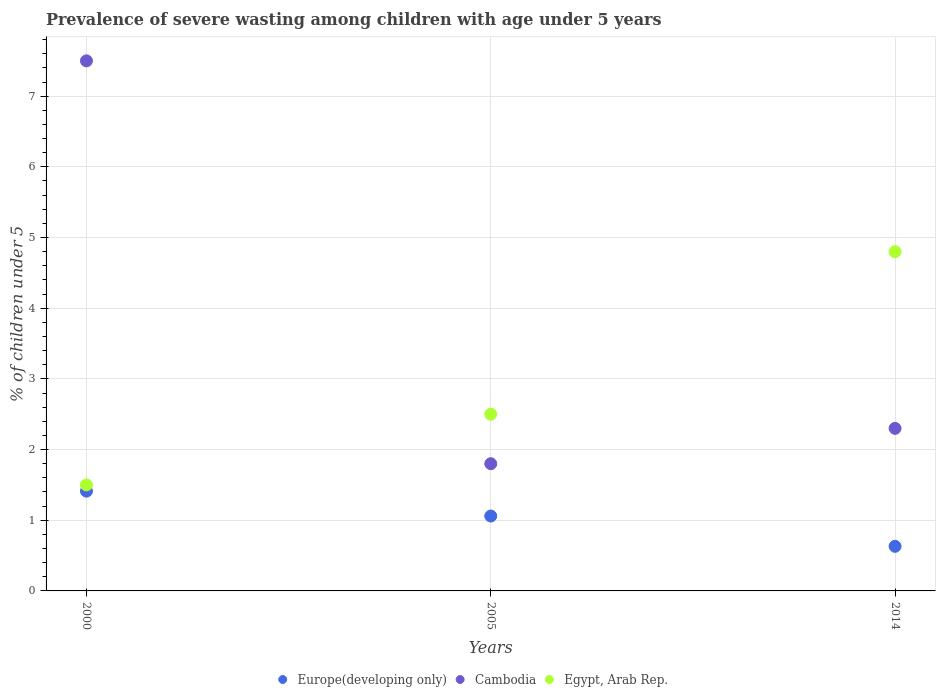How many different coloured dotlines are there?
Keep it short and to the point. 3. What is the percentage of severely wasted children in Europe(developing only) in 2005?
Your answer should be very brief. 1.06. Across all years, what is the maximum percentage of severely wasted children in Egypt, Arab Rep.?
Your answer should be very brief. 4.8. Across all years, what is the minimum percentage of severely wasted children in Cambodia?
Provide a short and direct response. 1.8. In which year was the percentage of severely wasted children in Egypt, Arab Rep. maximum?
Your answer should be compact. 2014. In which year was the percentage of severely wasted children in Egypt, Arab Rep. minimum?
Keep it short and to the point. 2000. What is the total percentage of severely wasted children in Europe(developing only) in the graph?
Ensure brevity in your answer.  3.1. What is the difference between the percentage of severely wasted children in Cambodia in 2000 and that in 2005?
Provide a short and direct response. 5.7. What is the difference between the percentage of severely wasted children in Egypt, Arab Rep. in 2014 and the percentage of severely wasted children in Europe(developing only) in 2005?
Offer a very short reply. 3.74. What is the average percentage of severely wasted children in Egypt, Arab Rep. per year?
Offer a terse response. 2.93. In the year 2000, what is the difference between the percentage of severely wasted children in Cambodia and percentage of severely wasted children in Europe(developing only)?
Your response must be concise. 6.09. In how many years, is the percentage of severely wasted children in Cambodia greater than 5.8 %?
Keep it short and to the point. 1. What is the ratio of the percentage of severely wasted children in Egypt, Arab Rep. in 2000 to that in 2014?
Provide a succinct answer. 0.31. What is the difference between the highest and the second highest percentage of severely wasted children in Cambodia?
Your response must be concise. 5.2. What is the difference between the highest and the lowest percentage of severely wasted children in Europe(developing only)?
Your answer should be compact. 0.78. In how many years, is the percentage of severely wasted children in Egypt, Arab Rep. greater than the average percentage of severely wasted children in Egypt, Arab Rep. taken over all years?
Ensure brevity in your answer.  1. Is the sum of the percentage of severely wasted children in Europe(developing only) in 2005 and 2014 greater than the maximum percentage of severely wasted children in Cambodia across all years?
Keep it short and to the point. No. Is the percentage of severely wasted children in Cambodia strictly greater than the percentage of severely wasted children in Europe(developing only) over the years?
Ensure brevity in your answer.  Yes. Is the percentage of severely wasted children in Europe(developing only) strictly less than the percentage of severely wasted children in Egypt, Arab Rep. over the years?
Give a very brief answer. Yes. How many dotlines are there?
Make the answer very short. 3. How many years are there in the graph?
Offer a terse response. 3. Does the graph contain grids?
Your answer should be compact. Yes. How many legend labels are there?
Keep it short and to the point. 3. How are the legend labels stacked?
Provide a short and direct response. Horizontal. What is the title of the graph?
Provide a succinct answer. Prevalence of severe wasting among children with age under 5 years. Does "Papua New Guinea" appear as one of the legend labels in the graph?
Offer a terse response. No. What is the label or title of the X-axis?
Offer a very short reply. Years. What is the label or title of the Y-axis?
Give a very brief answer. % of children under 5. What is the % of children under 5 of Europe(developing only) in 2000?
Your answer should be compact. 1.41. What is the % of children under 5 of Egypt, Arab Rep. in 2000?
Your answer should be compact. 1.5. What is the % of children under 5 of Europe(developing only) in 2005?
Give a very brief answer. 1.06. What is the % of children under 5 in Cambodia in 2005?
Your answer should be very brief. 1.8. What is the % of children under 5 of Europe(developing only) in 2014?
Offer a terse response. 0.63. What is the % of children under 5 of Cambodia in 2014?
Keep it short and to the point. 2.3. What is the % of children under 5 in Egypt, Arab Rep. in 2014?
Offer a very short reply. 4.8. Across all years, what is the maximum % of children under 5 of Europe(developing only)?
Ensure brevity in your answer.  1.41. Across all years, what is the maximum % of children under 5 in Egypt, Arab Rep.?
Ensure brevity in your answer.  4.8. Across all years, what is the minimum % of children under 5 in Europe(developing only)?
Your answer should be compact. 0.63. Across all years, what is the minimum % of children under 5 in Cambodia?
Offer a very short reply. 1.8. Across all years, what is the minimum % of children under 5 in Egypt, Arab Rep.?
Ensure brevity in your answer.  1.5. What is the total % of children under 5 in Europe(developing only) in the graph?
Your response must be concise. 3.1. What is the total % of children under 5 of Cambodia in the graph?
Provide a short and direct response. 11.6. What is the total % of children under 5 in Egypt, Arab Rep. in the graph?
Your response must be concise. 8.8. What is the difference between the % of children under 5 of Europe(developing only) in 2000 and that in 2005?
Give a very brief answer. 0.35. What is the difference between the % of children under 5 of Europe(developing only) in 2000 and that in 2014?
Keep it short and to the point. 0.78. What is the difference between the % of children under 5 of Cambodia in 2000 and that in 2014?
Offer a very short reply. 5.2. What is the difference between the % of children under 5 of Egypt, Arab Rep. in 2000 and that in 2014?
Offer a very short reply. -3.3. What is the difference between the % of children under 5 in Europe(developing only) in 2005 and that in 2014?
Your answer should be compact. 0.43. What is the difference between the % of children under 5 of Egypt, Arab Rep. in 2005 and that in 2014?
Your answer should be very brief. -2.3. What is the difference between the % of children under 5 in Europe(developing only) in 2000 and the % of children under 5 in Cambodia in 2005?
Your response must be concise. -0.39. What is the difference between the % of children under 5 of Europe(developing only) in 2000 and the % of children under 5 of Egypt, Arab Rep. in 2005?
Your answer should be compact. -1.09. What is the difference between the % of children under 5 in Cambodia in 2000 and the % of children under 5 in Egypt, Arab Rep. in 2005?
Keep it short and to the point. 5. What is the difference between the % of children under 5 in Europe(developing only) in 2000 and the % of children under 5 in Cambodia in 2014?
Your answer should be very brief. -0.89. What is the difference between the % of children under 5 of Europe(developing only) in 2000 and the % of children under 5 of Egypt, Arab Rep. in 2014?
Offer a terse response. -3.39. What is the difference between the % of children under 5 in Europe(developing only) in 2005 and the % of children under 5 in Cambodia in 2014?
Keep it short and to the point. -1.24. What is the difference between the % of children under 5 of Europe(developing only) in 2005 and the % of children under 5 of Egypt, Arab Rep. in 2014?
Provide a short and direct response. -3.74. What is the difference between the % of children under 5 in Cambodia in 2005 and the % of children under 5 in Egypt, Arab Rep. in 2014?
Provide a short and direct response. -3. What is the average % of children under 5 of Europe(developing only) per year?
Your response must be concise. 1.03. What is the average % of children under 5 in Cambodia per year?
Your response must be concise. 3.87. What is the average % of children under 5 of Egypt, Arab Rep. per year?
Provide a short and direct response. 2.93. In the year 2000, what is the difference between the % of children under 5 of Europe(developing only) and % of children under 5 of Cambodia?
Your answer should be very brief. -6.09. In the year 2000, what is the difference between the % of children under 5 of Europe(developing only) and % of children under 5 of Egypt, Arab Rep.?
Keep it short and to the point. -0.09. In the year 2000, what is the difference between the % of children under 5 of Cambodia and % of children under 5 of Egypt, Arab Rep.?
Your response must be concise. 6. In the year 2005, what is the difference between the % of children under 5 in Europe(developing only) and % of children under 5 in Cambodia?
Provide a short and direct response. -0.74. In the year 2005, what is the difference between the % of children under 5 of Europe(developing only) and % of children under 5 of Egypt, Arab Rep.?
Your response must be concise. -1.44. In the year 2014, what is the difference between the % of children under 5 in Europe(developing only) and % of children under 5 in Cambodia?
Keep it short and to the point. -1.67. In the year 2014, what is the difference between the % of children under 5 of Europe(developing only) and % of children under 5 of Egypt, Arab Rep.?
Offer a very short reply. -4.17. In the year 2014, what is the difference between the % of children under 5 in Cambodia and % of children under 5 in Egypt, Arab Rep.?
Your answer should be very brief. -2.5. What is the ratio of the % of children under 5 of Europe(developing only) in 2000 to that in 2005?
Give a very brief answer. 1.33. What is the ratio of the % of children under 5 of Cambodia in 2000 to that in 2005?
Keep it short and to the point. 4.17. What is the ratio of the % of children under 5 of Europe(developing only) in 2000 to that in 2014?
Make the answer very short. 2.24. What is the ratio of the % of children under 5 of Cambodia in 2000 to that in 2014?
Keep it short and to the point. 3.26. What is the ratio of the % of children under 5 of Egypt, Arab Rep. in 2000 to that in 2014?
Offer a very short reply. 0.31. What is the ratio of the % of children under 5 in Europe(developing only) in 2005 to that in 2014?
Provide a succinct answer. 1.68. What is the ratio of the % of children under 5 of Cambodia in 2005 to that in 2014?
Your answer should be compact. 0.78. What is the ratio of the % of children under 5 in Egypt, Arab Rep. in 2005 to that in 2014?
Ensure brevity in your answer.  0.52. What is the difference between the highest and the second highest % of children under 5 of Europe(developing only)?
Your answer should be very brief. 0.35. What is the difference between the highest and the second highest % of children under 5 of Cambodia?
Your response must be concise. 5.2. What is the difference between the highest and the second highest % of children under 5 in Egypt, Arab Rep.?
Give a very brief answer. 2.3. What is the difference between the highest and the lowest % of children under 5 in Europe(developing only)?
Keep it short and to the point. 0.78. What is the difference between the highest and the lowest % of children under 5 in Cambodia?
Give a very brief answer. 5.7. 